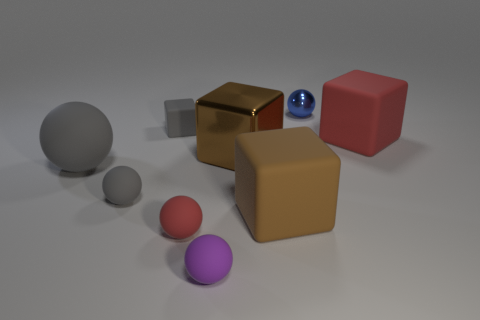There is a object that is behind the tiny rubber thing behind the large rubber object on the left side of the small purple sphere; what is its material?
Give a very brief answer. Metal. How many other things are there of the same size as the purple rubber thing?
Your response must be concise. 4. There is another ball that is the same color as the big matte sphere; what is its size?
Your response must be concise. Small. Is the number of blue balls on the right side of the small gray block greater than the number of tiny red metal spheres?
Offer a terse response. Yes. Is there a small object that has the same color as the big matte sphere?
Make the answer very short. Yes. The metal cube that is the same size as the red rubber cube is what color?
Offer a very short reply. Brown. There is a red matte thing that is on the left side of the blue shiny object; what number of shiny balls are in front of it?
Give a very brief answer. 0. What number of things are cubes that are behind the brown rubber object or gray matte balls?
Offer a very short reply. 5. How many tiny gray things are the same material as the purple object?
Keep it short and to the point. 2. What shape is the large object that is the same color as the large metallic cube?
Provide a short and direct response. Cube. 